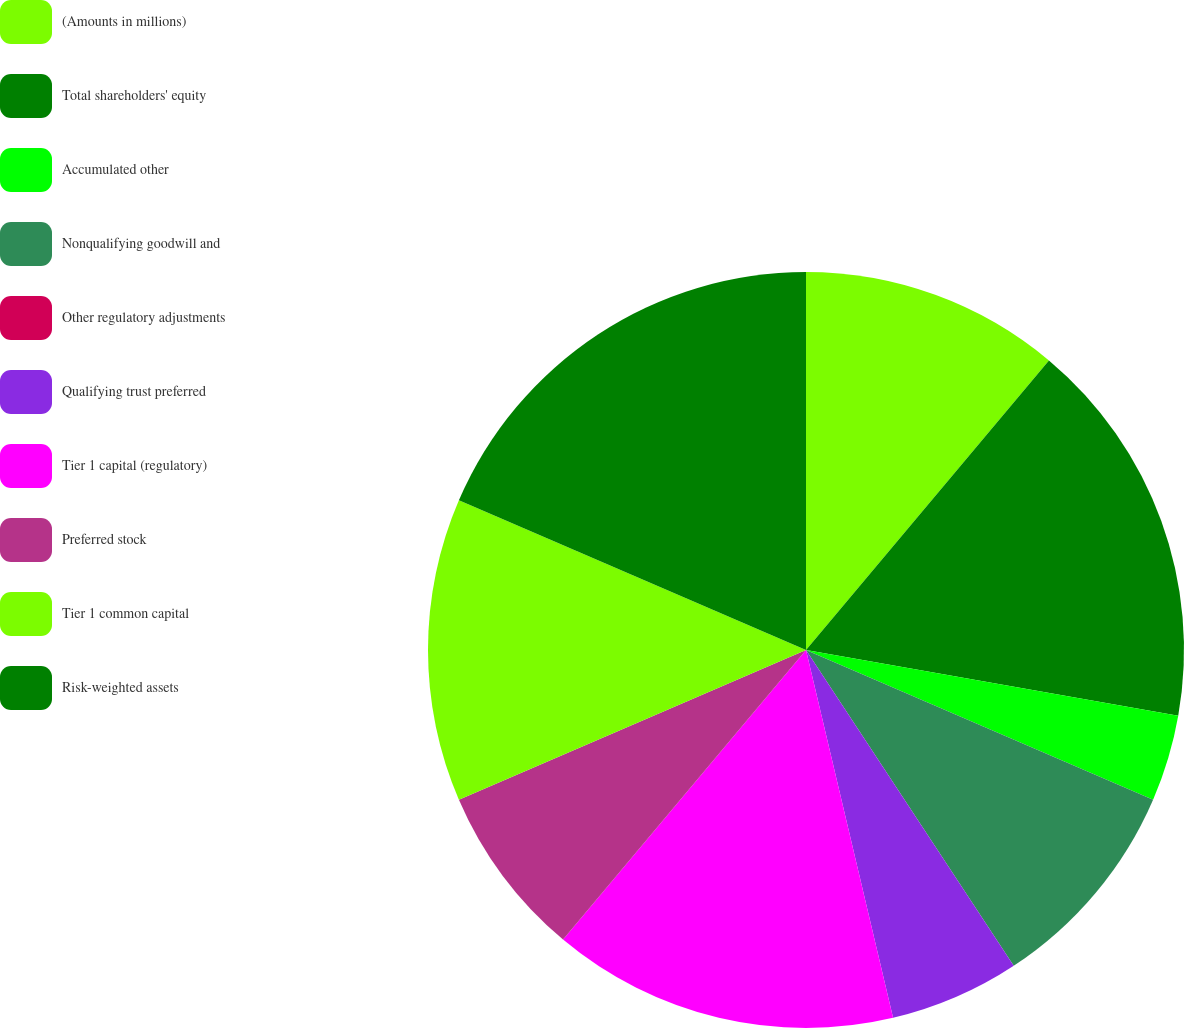Convert chart. <chart><loc_0><loc_0><loc_500><loc_500><pie_chart><fcel>(Amounts in millions)<fcel>Total shareholders' equity<fcel>Accumulated other<fcel>Nonqualifying goodwill and<fcel>Other regulatory adjustments<fcel>Qualifying trust preferred<fcel>Tier 1 capital (regulatory)<fcel>Preferred stock<fcel>Tier 1 common capital<fcel>Risk-weighted assets<nl><fcel>11.11%<fcel>16.67%<fcel>3.7%<fcel>9.26%<fcel>0.0%<fcel>5.56%<fcel>14.81%<fcel>7.41%<fcel>12.96%<fcel>18.52%<nl></chart> 